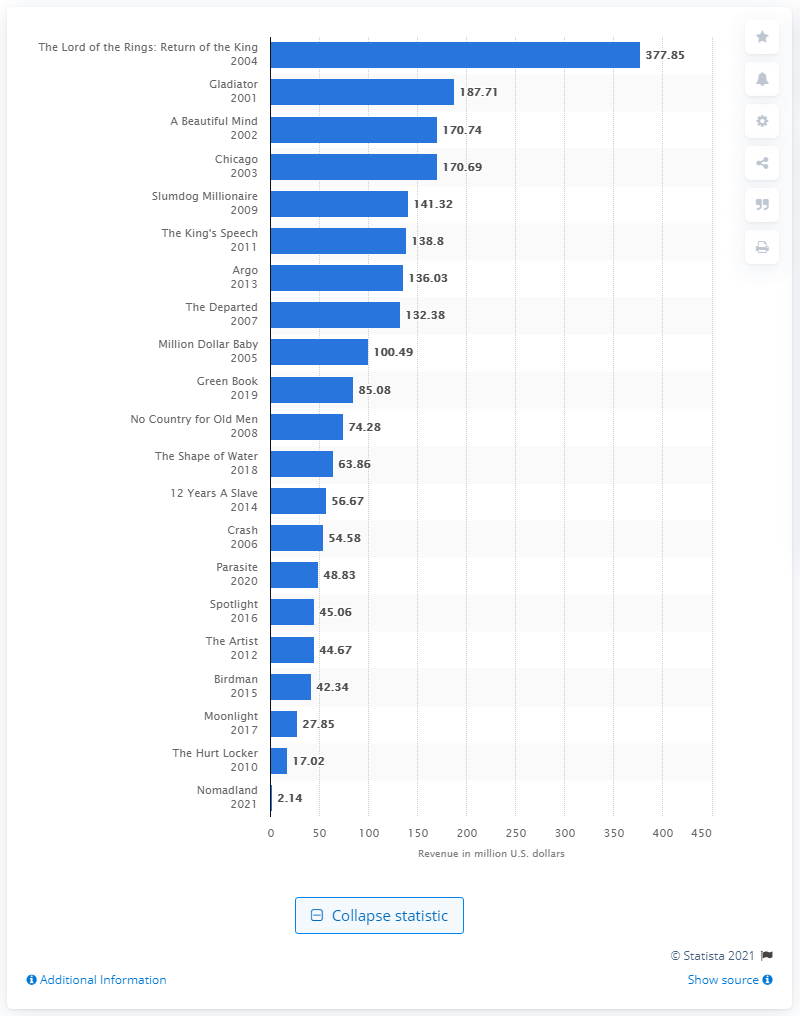Outline some significant characteristics in this image. According to data available as of April 2021, the box office earnings of the film "Nomadland" in the United States and Canada were approximately 2.14 million dollars. 